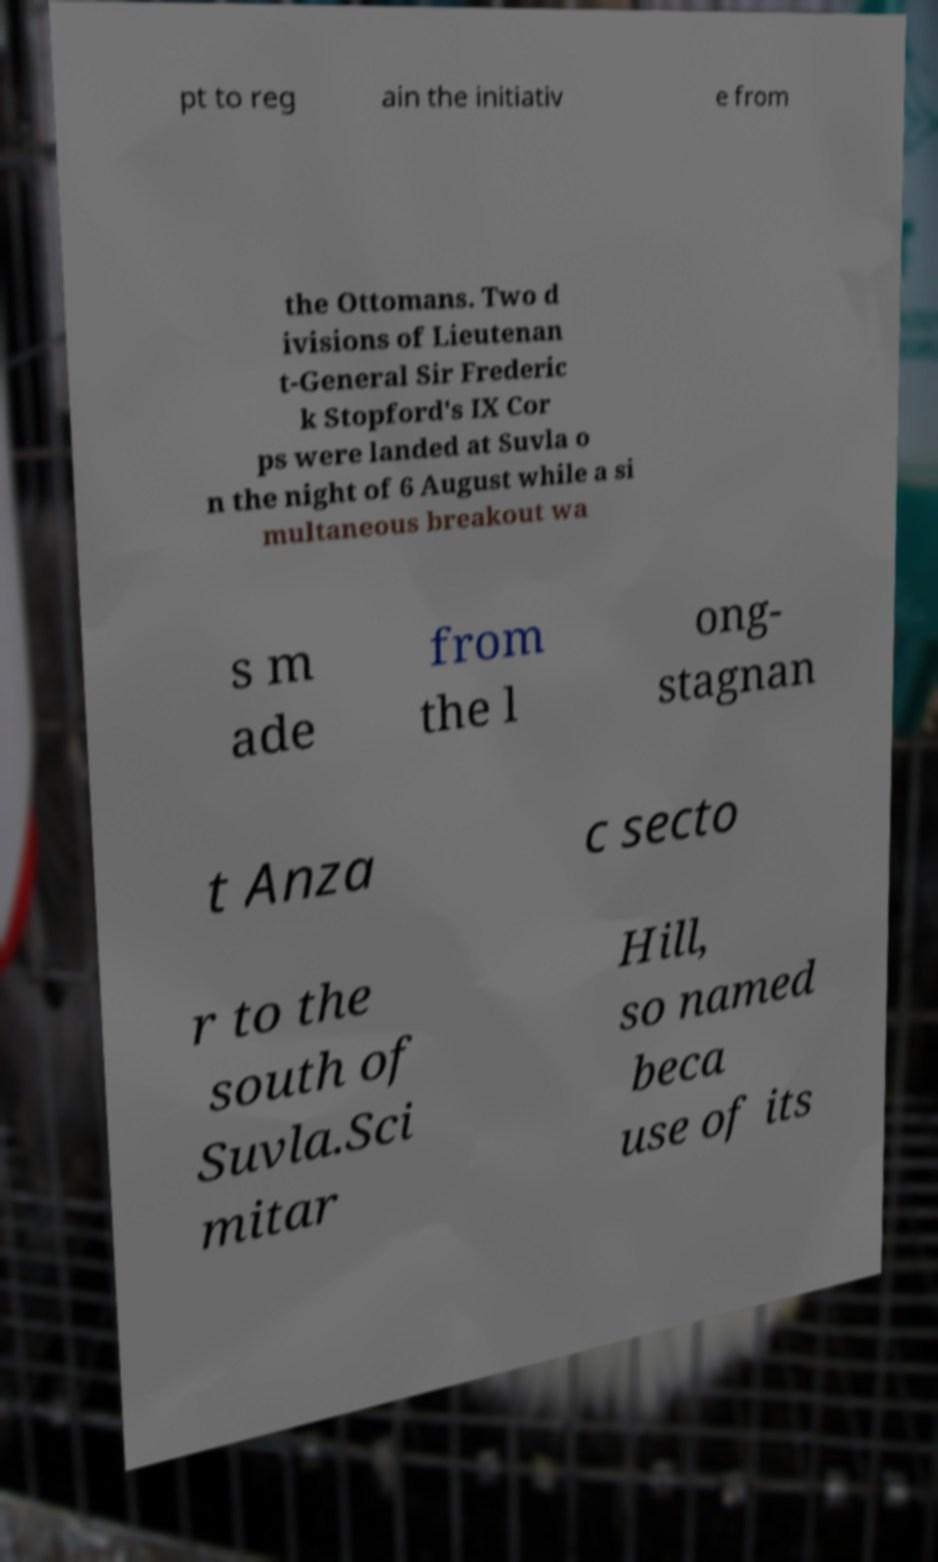What messages or text are displayed in this image? I need them in a readable, typed format. pt to reg ain the initiativ e from the Ottomans. Two d ivisions of Lieutenan t-General Sir Frederic k Stopford's IX Cor ps were landed at Suvla o n the night of 6 August while a si multaneous breakout wa s m ade from the l ong- stagnan t Anza c secto r to the south of Suvla.Sci mitar Hill, so named beca use of its 